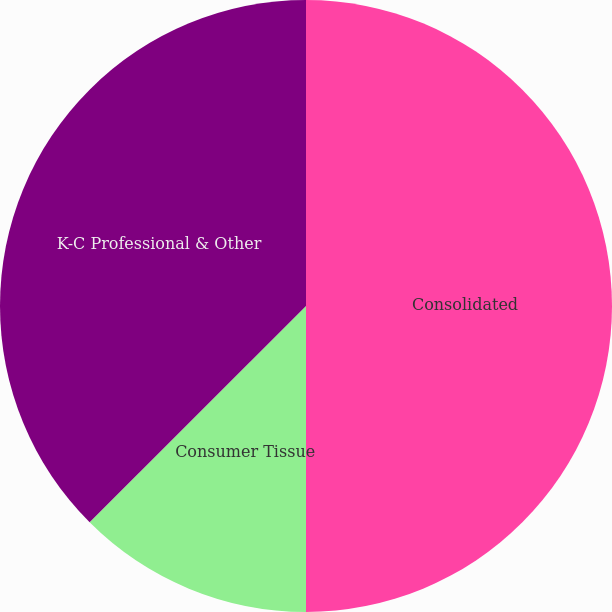Convert chart to OTSL. <chart><loc_0><loc_0><loc_500><loc_500><pie_chart><fcel>Consolidated<fcel>Consumer Tissue<fcel>K-C Professional & Other<nl><fcel>50.0%<fcel>12.5%<fcel>37.5%<nl></chart> 